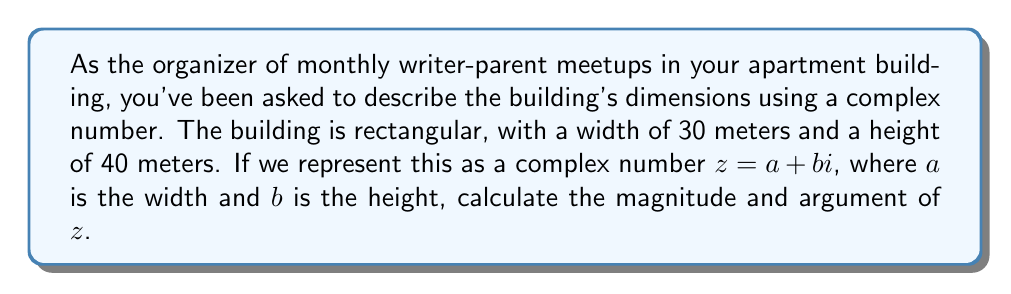Show me your answer to this math problem. To solve this problem, we'll follow these steps:

1) First, we need to express the building's dimensions as a complex number:
   $z = 30 + 40i$

2) To calculate the magnitude of $z$, we use the formula:
   $|z| = \sqrt{a^2 + b^2}$
   
   Where $a$ is the real part and $b$ is the imaginary part.

3) Substituting our values:
   $|z| = \sqrt{30^2 + 40^2}$
   $|z| = \sqrt{900 + 1600}$
   $|z| = \sqrt{2500}$
   $|z| = 50$

4) To calculate the argument of $z$, we use the formula:
   $\arg(z) = \tan^{-1}(\frac{b}{a})$

5) Substituting our values:
   $\arg(z) = \tan^{-1}(\frac{40}{30})$
   $\arg(z) = \tan^{-1}(\frac{4}{3})$
   $\arg(z) \approx 0.9272952180$ radians

6) To convert radians to degrees:
   $\arg(z) \approx 0.9272952180 \times \frac{180}{\pi} \approx 53.13010235^\circ$

Therefore, the magnitude of $z$ is 50 meters, and its argument is approximately 53.13 degrees.
Answer: $|z| = 50$, $\arg(z) \approx 53.13^\circ$ 